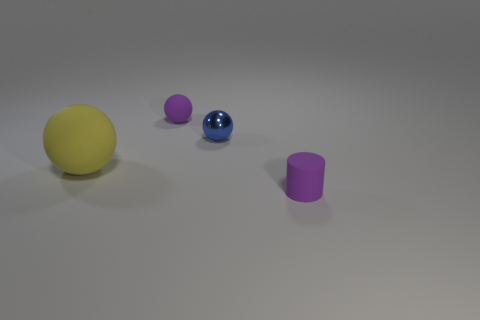Subtract all rubber balls. How many balls are left? 1 Subtract all blue spheres. How many spheres are left? 2 Add 3 tiny green cubes. How many objects exist? 7 Subtract 2 balls. How many balls are left? 1 Subtract all spheres. How many objects are left? 1 Subtract all gray cylinders. How many blue spheres are left? 1 Add 2 metal objects. How many metal objects are left? 3 Add 3 big gray metallic things. How many big gray metallic things exist? 3 Subtract 0 brown balls. How many objects are left? 4 Subtract all gray balls. Subtract all green cylinders. How many balls are left? 3 